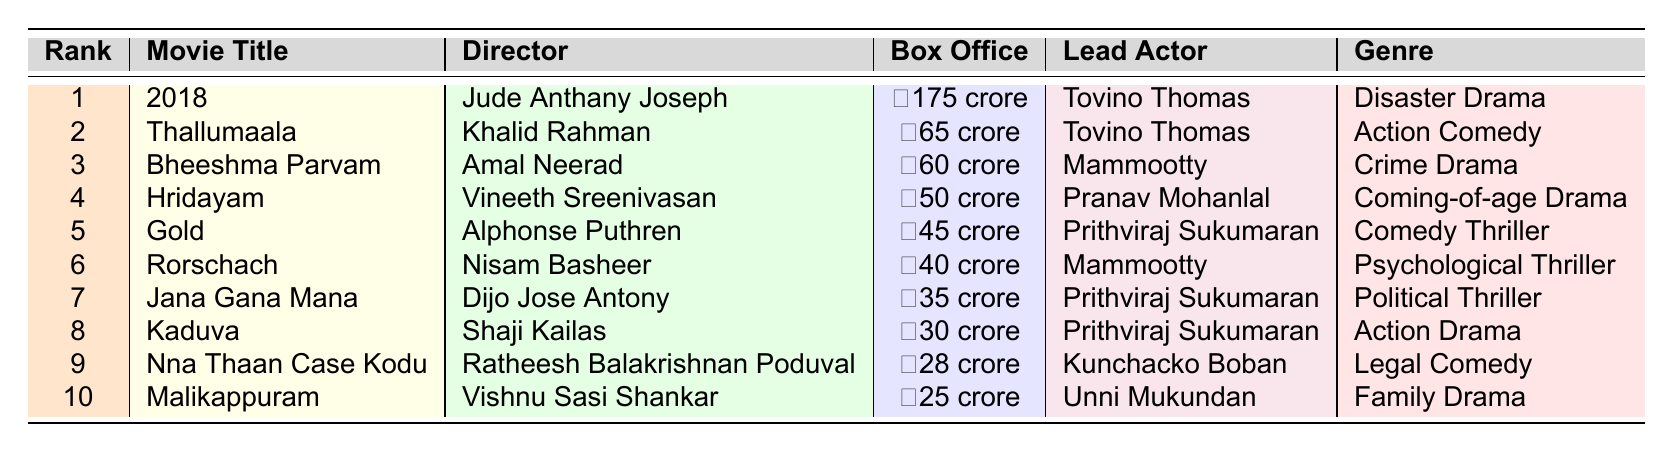What is the box office collection of the movie "2018"? The table lists the box office collection for "2018" as ₹175 crore.
Answer: ₹175 crore Which actor starred in "Hridayam"? The table indicates that the lead actor in "Hridayam" is Pranav Mohanlal.
Answer: Pranav Mohanlal What is the genre of "Kaduva"? According to the table, "Kaduva" is categorized as an Action Drama.
Answer: Action Drama How many movies collected over ₹50 crore at the box office? The table shows that "2018", "Thallumaala", and "Bheeshma Parvam" are the only movies with collections above ₹50 crore, totaling three movies.
Answer: 3 Which movie had the highest box office collection, and who directed it? The table reveals that "2018" had the highest collection of ₹175 crore, directed by Jude Anthany Joseph.
Answer: "2018", Jude Anthany Joseph Is there a movie in the top 10 that has a box office collection between ₹25 crore and ₹30 crore? The table indicates that "Malikappuram" with ₹25 crore and "Nna Thaan Case Kodu" with ₹28 crore fall within that range, confirming there are movies in that bracket.
Answer: Yes What is the average box office collection of the top three movies? The top three movies are "2018" (₹175 crore), "Thallumaala" (₹65 crore), and "Bheeshma Parvam" (₹60 crore). Summing these gives ₹175 + ₹65 + ₹60 = ₹300 crore. Dividing by 3, the average is ₹100 crore.
Answer: ₹100 crore Which director has the most movies in the top 10? By reviewing the table, we see that Prithviraj Sukumaran starred in three movies: "Gold", "Jana Gana Mana", and "Kaduva". Hence, this indicates he is featured in the most movies in the top 10.
Answer: Prithviraj Sukumaran What is the total box office collection of movies directed by Mammootty? The box office collections of the movies directed by Mammootty, which are "Bheeshma Parvam" (₹60 crore) and "Rorschach" (₹40 crore), can be summed: ₹60 + ₹40 = ₹100 crore.
Answer: ₹100 crore Which movie has a box office collection closest to ₹30 crore? The table indicates that "Kaduva" with ₹30 crore exactly matches, while "Nna Thaan Case Kodu" with ₹28 crore is the next closest.
Answer: "Kaduva" 